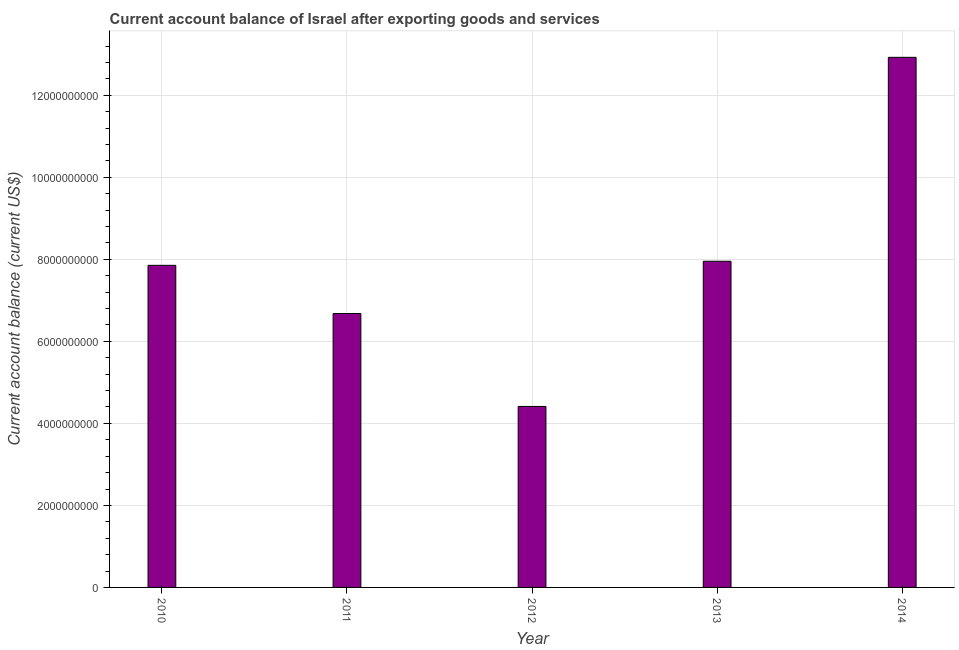Does the graph contain any zero values?
Your response must be concise. No. Does the graph contain grids?
Offer a terse response. Yes. What is the title of the graph?
Your response must be concise. Current account balance of Israel after exporting goods and services. What is the label or title of the Y-axis?
Provide a short and direct response. Current account balance (current US$). What is the current account balance in 2013?
Offer a very short reply. 7.95e+09. Across all years, what is the maximum current account balance?
Your answer should be very brief. 1.29e+1. Across all years, what is the minimum current account balance?
Ensure brevity in your answer.  4.41e+09. In which year was the current account balance minimum?
Your answer should be very brief. 2012. What is the sum of the current account balance?
Give a very brief answer. 3.98e+1. What is the difference between the current account balance in 2011 and 2012?
Offer a terse response. 2.26e+09. What is the average current account balance per year?
Offer a terse response. 7.97e+09. What is the median current account balance?
Provide a short and direct response. 7.85e+09. In how many years, is the current account balance greater than 5200000000 US$?
Your answer should be very brief. 4. What is the ratio of the current account balance in 2012 to that in 2013?
Your answer should be very brief. 0.56. Is the current account balance in 2010 less than that in 2012?
Ensure brevity in your answer.  No. Is the difference between the current account balance in 2010 and 2013 greater than the difference between any two years?
Give a very brief answer. No. What is the difference between the highest and the second highest current account balance?
Give a very brief answer. 4.97e+09. What is the difference between the highest and the lowest current account balance?
Offer a very short reply. 8.51e+09. How many bars are there?
Offer a very short reply. 5. Are all the bars in the graph horizontal?
Provide a succinct answer. No. What is the difference between two consecutive major ticks on the Y-axis?
Keep it short and to the point. 2.00e+09. Are the values on the major ticks of Y-axis written in scientific E-notation?
Your answer should be very brief. No. What is the Current account balance (current US$) in 2010?
Offer a terse response. 7.85e+09. What is the Current account balance (current US$) in 2011?
Ensure brevity in your answer.  6.68e+09. What is the Current account balance (current US$) of 2012?
Offer a very short reply. 4.41e+09. What is the Current account balance (current US$) of 2013?
Ensure brevity in your answer.  7.95e+09. What is the Current account balance (current US$) of 2014?
Your response must be concise. 1.29e+1. What is the difference between the Current account balance (current US$) in 2010 and 2011?
Provide a short and direct response. 1.18e+09. What is the difference between the Current account balance (current US$) in 2010 and 2012?
Offer a terse response. 3.44e+09. What is the difference between the Current account balance (current US$) in 2010 and 2013?
Provide a succinct answer. -9.94e+07. What is the difference between the Current account balance (current US$) in 2010 and 2014?
Ensure brevity in your answer.  -5.07e+09. What is the difference between the Current account balance (current US$) in 2011 and 2012?
Ensure brevity in your answer.  2.26e+09. What is the difference between the Current account balance (current US$) in 2011 and 2013?
Your answer should be compact. -1.28e+09. What is the difference between the Current account balance (current US$) in 2011 and 2014?
Make the answer very short. -6.25e+09. What is the difference between the Current account balance (current US$) in 2012 and 2013?
Keep it short and to the point. -3.54e+09. What is the difference between the Current account balance (current US$) in 2012 and 2014?
Keep it short and to the point. -8.51e+09. What is the difference between the Current account balance (current US$) in 2013 and 2014?
Give a very brief answer. -4.97e+09. What is the ratio of the Current account balance (current US$) in 2010 to that in 2011?
Give a very brief answer. 1.18. What is the ratio of the Current account balance (current US$) in 2010 to that in 2012?
Give a very brief answer. 1.78. What is the ratio of the Current account balance (current US$) in 2010 to that in 2014?
Your response must be concise. 0.61. What is the ratio of the Current account balance (current US$) in 2011 to that in 2012?
Offer a very short reply. 1.51. What is the ratio of the Current account balance (current US$) in 2011 to that in 2013?
Your response must be concise. 0.84. What is the ratio of the Current account balance (current US$) in 2011 to that in 2014?
Give a very brief answer. 0.52. What is the ratio of the Current account balance (current US$) in 2012 to that in 2013?
Your answer should be compact. 0.56. What is the ratio of the Current account balance (current US$) in 2012 to that in 2014?
Your answer should be very brief. 0.34. What is the ratio of the Current account balance (current US$) in 2013 to that in 2014?
Your response must be concise. 0.61. 